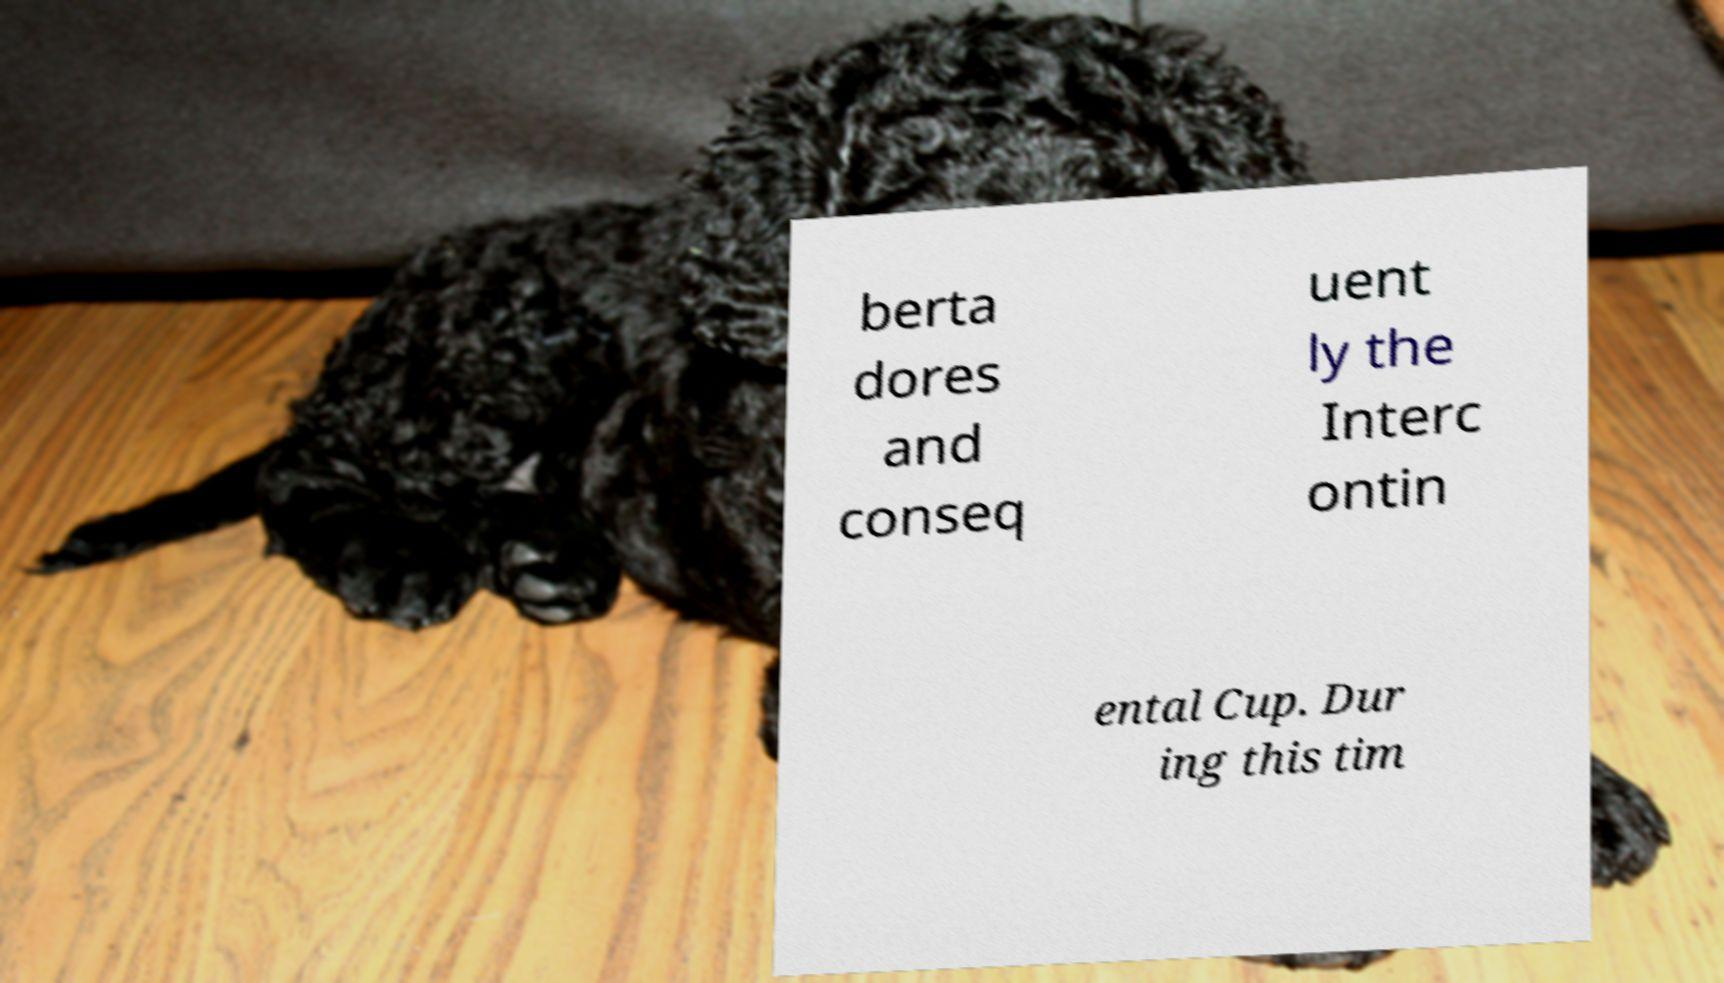Can you read and provide the text displayed in the image?This photo seems to have some interesting text. Can you extract and type it out for me? berta dores and conseq uent ly the Interc ontin ental Cup. Dur ing this tim 